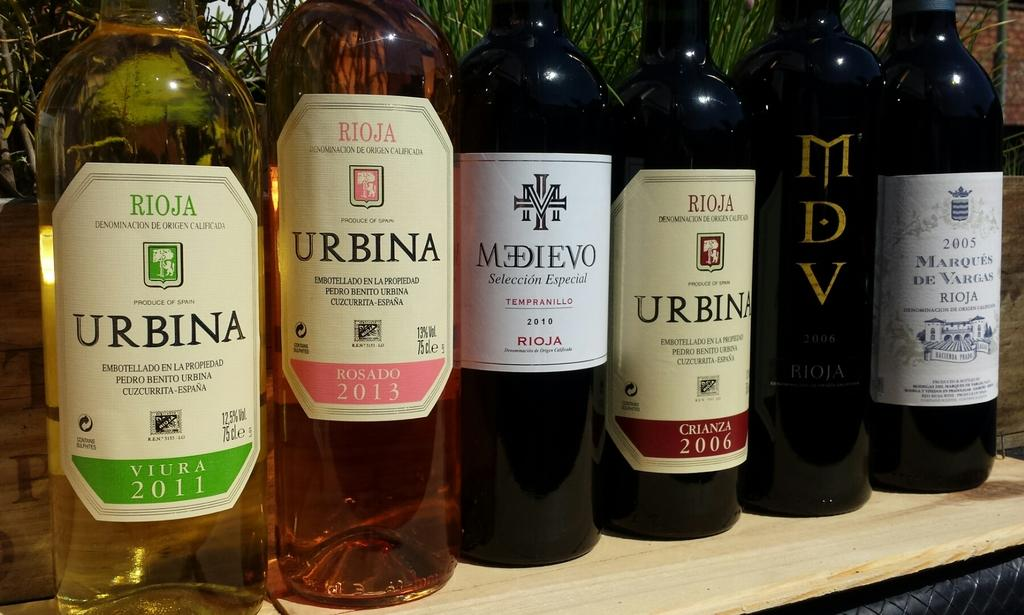<image>
Render a clear and concise summary of the photo. A row of wine bottles contain several Urbina varieties from assorted vintages. 